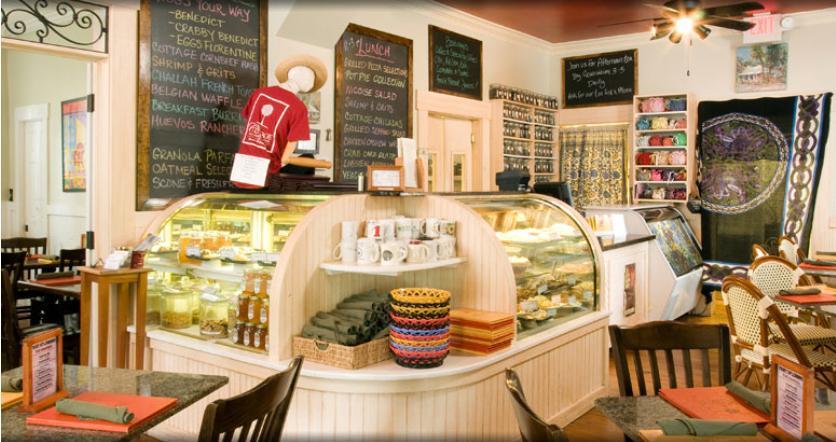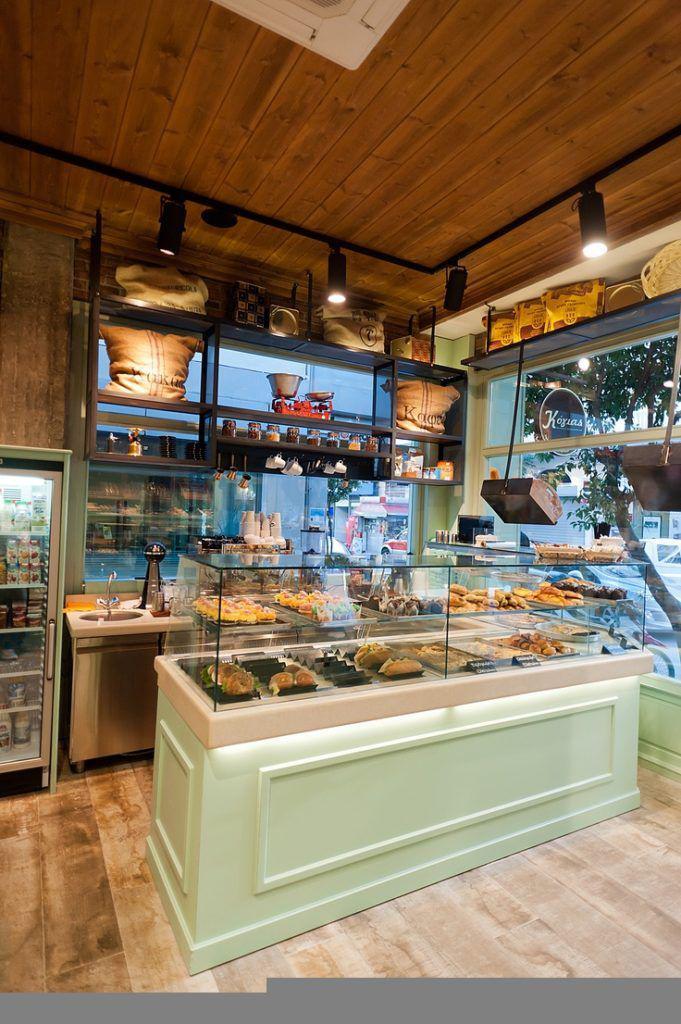The first image is the image on the left, the second image is the image on the right. For the images shown, is this caption "One display cabinet is a soft green color." true? Answer yes or no. Yes. 